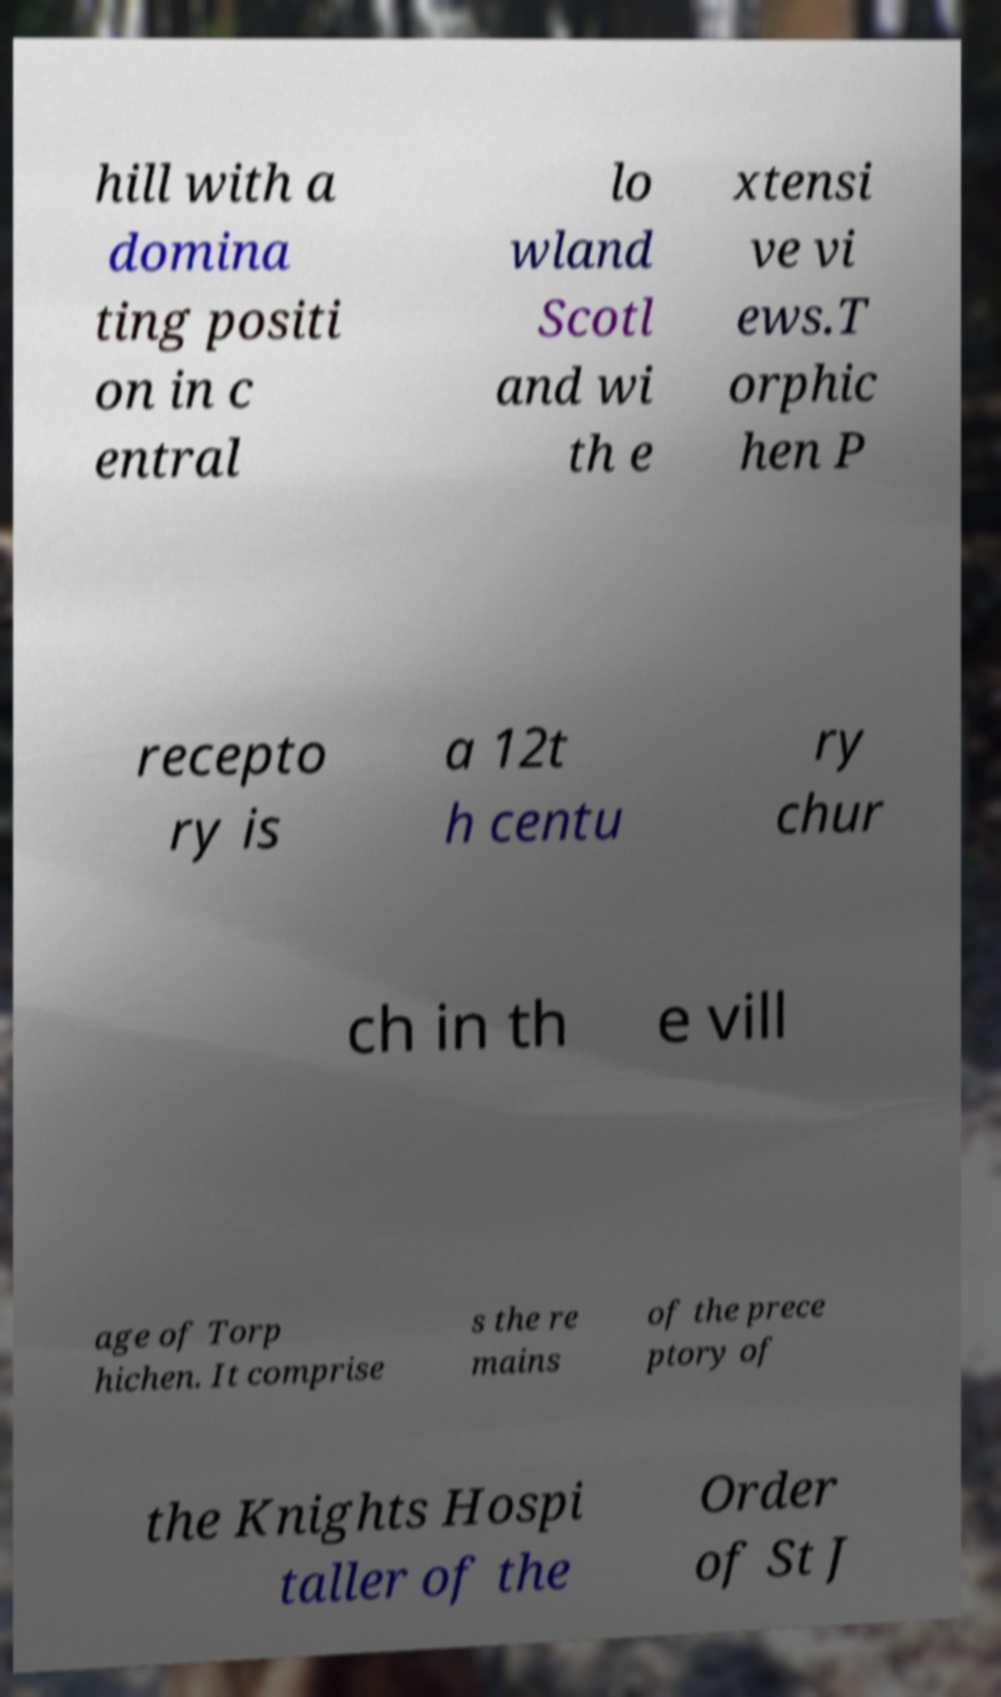What messages or text are displayed in this image? I need them in a readable, typed format. hill with a domina ting positi on in c entral lo wland Scotl and wi th e xtensi ve vi ews.T orphic hen P recepto ry is a 12t h centu ry chur ch in th e vill age of Torp hichen. It comprise s the re mains of the prece ptory of the Knights Hospi taller of the Order of St J 